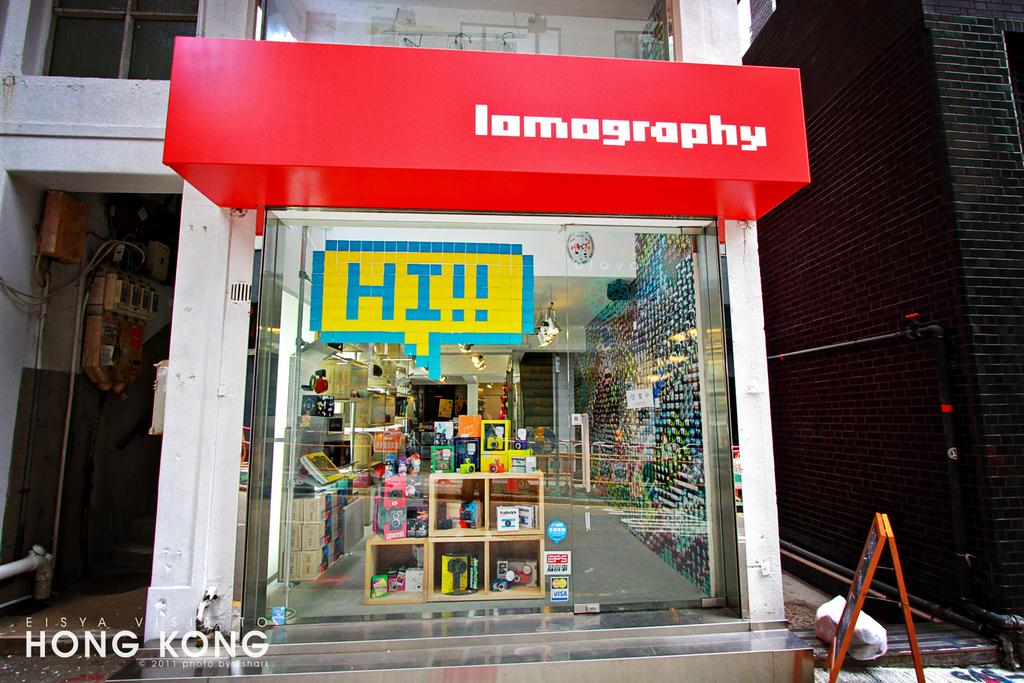What greeting is written on the stores window?
Make the answer very short. Hi!!. 